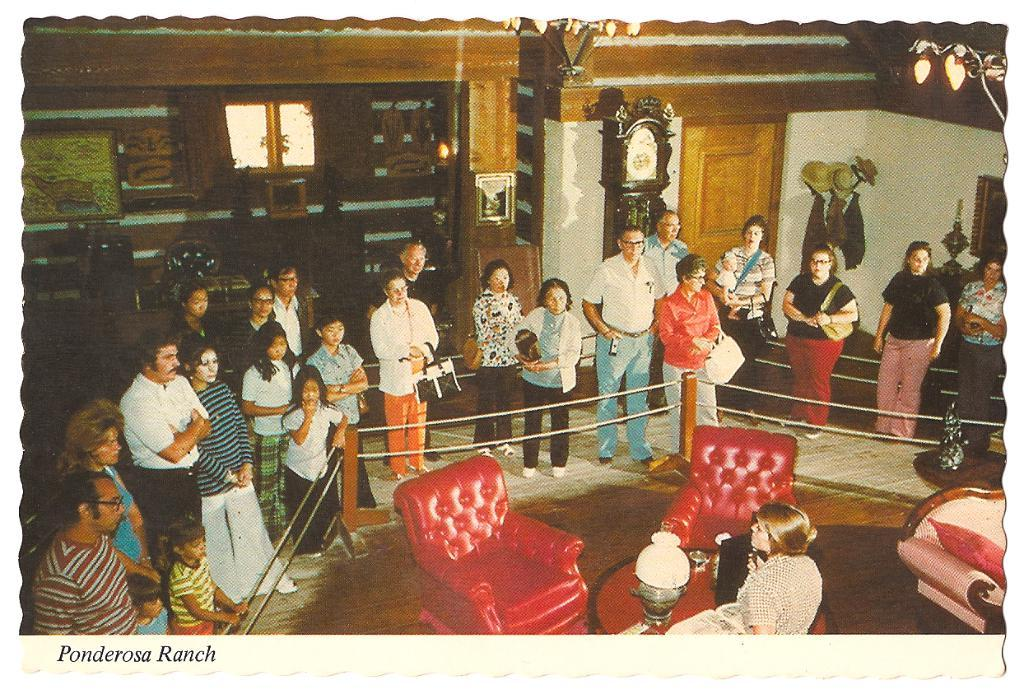<image>
Offer a succinct explanation of the picture presented. A large group of people gathered at the Ponderosa ranch 